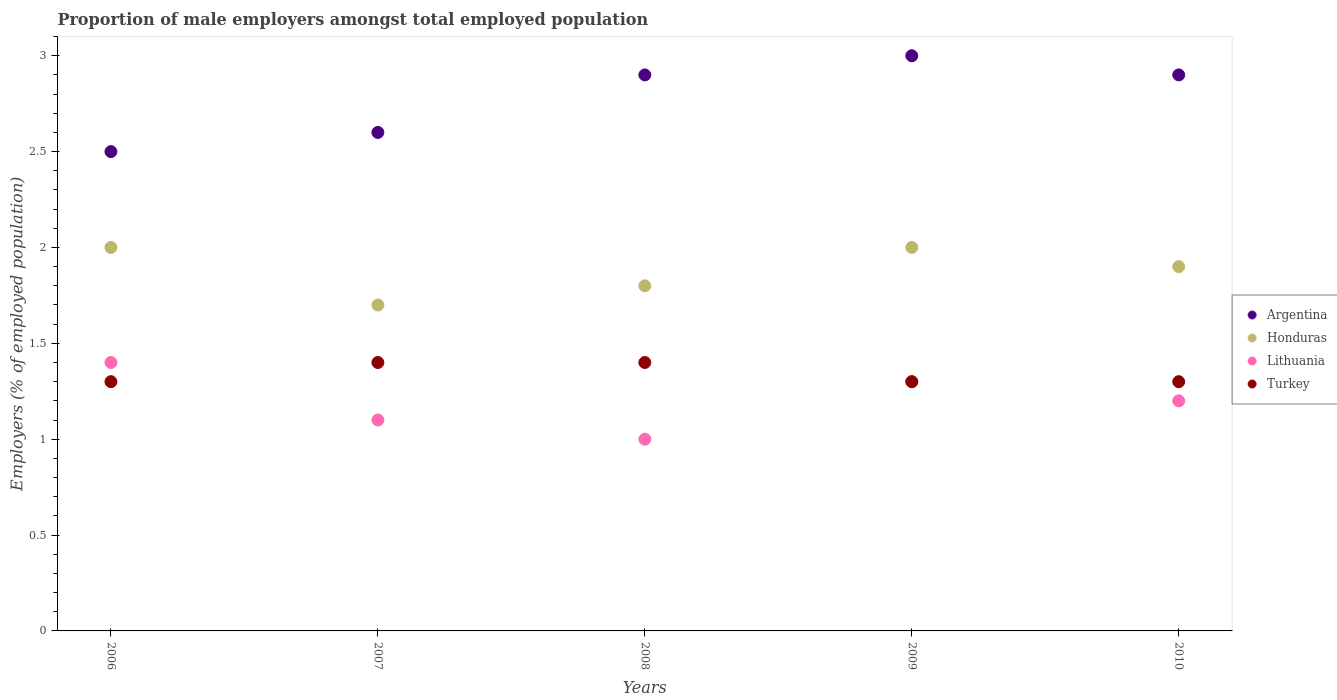Is the number of dotlines equal to the number of legend labels?
Give a very brief answer. Yes. Across all years, what is the maximum proportion of male employers in Turkey?
Your response must be concise. 1.4. Across all years, what is the minimum proportion of male employers in Lithuania?
Offer a terse response. 1. In which year was the proportion of male employers in Turkey minimum?
Your answer should be compact. 2006. What is the total proportion of male employers in Honduras in the graph?
Ensure brevity in your answer.  9.4. What is the difference between the proportion of male employers in Turkey in 2006 and that in 2010?
Keep it short and to the point. 0. What is the difference between the proportion of male employers in Honduras in 2006 and the proportion of male employers in Argentina in 2007?
Offer a very short reply. -0.6. What is the average proportion of male employers in Argentina per year?
Offer a terse response. 2.78. In the year 2010, what is the difference between the proportion of male employers in Lithuania and proportion of male employers in Turkey?
Make the answer very short. -0.1. In how many years, is the proportion of male employers in Lithuania greater than 1.8 %?
Provide a succinct answer. 0. What is the ratio of the proportion of male employers in Lithuania in 2008 to that in 2010?
Ensure brevity in your answer.  0.83. What is the difference between the highest and the second highest proportion of male employers in Honduras?
Your response must be concise. 0. What is the difference between the highest and the lowest proportion of male employers in Lithuania?
Ensure brevity in your answer.  0.4. In how many years, is the proportion of male employers in Honduras greater than the average proportion of male employers in Honduras taken over all years?
Your answer should be compact. 3. Is the sum of the proportion of male employers in Argentina in 2007 and 2010 greater than the maximum proportion of male employers in Honduras across all years?
Your answer should be very brief. Yes. Is the proportion of male employers in Honduras strictly greater than the proportion of male employers in Turkey over the years?
Your response must be concise. Yes. Is the proportion of male employers in Honduras strictly less than the proportion of male employers in Lithuania over the years?
Your response must be concise. No. How many years are there in the graph?
Your answer should be very brief. 5. Are the values on the major ticks of Y-axis written in scientific E-notation?
Your response must be concise. No. Does the graph contain grids?
Make the answer very short. No. How are the legend labels stacked?
Provide a short and direct response. Vertical. What is the title of the graph?
Make the answer very short. Proportion of male employers amongst total employed population. What is the label or title of the X-axis?
Provide a short and direct response. Years. What is the label or title of the Y-axis?
Your answer should be very brief. Employers (% of employed population). What is the Employers (% of employed population) in Argentina in 2006?
Give a very brief answer. 2.5. What is the Employers (% of employed population) in Honduras in 2006?
Your response must be concise. 2. What is the Employers (% of employed population) in Lithuania in 2006?
Make the answer very short. 1.4. What is the Employers (% of employed population) in Turkey in 2006?
Make the answer very short. 1.3. What is the Employers (% of employed population) in Argentina in 2007?
Offer a terse response. 2.6. What is the Employers (% of employed population) of Honduras in 2007?
Give a very brief answer. 1.7. What is the Employers (% of employed population) of Lithuania in 2007?
Your answer should be very brief. 1.1. What is the Employers (% of employed population) in Turkey in 2007?
Your answer should be very brief. 1.4. What is the Employers (% of employed population) of Argentina in 2008?
Offer a terse response. 2.9. What is the Employers (% of employed population) in Honduras in 2008?
Offer a very short reply. 1.8. What is the Employers (% of employed population) in Turkey in 2008?
Your answer should be very brief. 1.4. What is the Employers (% of employed population) in Argentina in 2009?
Make the answer very short. 3. What is the Employers (% of employed population) of Honduras in 2009?
Provide a succinct answer. 2. What is the Employers (% of employed population) of Lithuania in 2009?
Provide a succinct answer. 1.3. What is the Employers (% of employed population) of Turkey in 2009?
Your answer should be very brief. 1.3. What is the Employers (% of employed population) of Argentina in 2010?
Your answer should be compact. 2.9. What is the Employers (% of employed population) of Honduras in 2010?
Make the answer very short. 1.9. What is the Employers (% of employed population) of Lithuania in 2010?
Offer a very short reply. 1.2. What is the Employers (% of employed population) in Turkey in 2010?
Offer a terse response. 1.3. Across all years, what is the maximum Employers (% of employed population) of Honduras?
Make the answer very short. 2. Across all years, what is the maximum Employers (% of employed population) in Lithuania?
Your response must be concise. 1.4. Across all years, what is the maximum Employers (% of employed population) in Turkey?
Give a very brief answer. 1.4. Across all years, what is the minimum Employers (% of employed population) of Argentina?
Give a very brief answer. 2.5. Across all years, what is the minimum Employers (% of employed population) of Honduras?
Your answer should be compact. 1.7. Across all years, what is the minimum Employers (% of employed population) of Lithuania?
Keep it short and to the point. 1. Across all years, what is the minimum Employers (% of employed population) in Turkey?
Your response must be concise. 1.3. What is the total Employers (% of employed population) of Argentina in the graph?
Your response must be concise. 13.9. What is the total Employers (% of employed population) of Honduras in the graph?
Your answer should be very brief. 9.4. What is the total Employers (% of employed population) of Lithuania in the graph?
Make the answer very short. 6. What is the difference between the Employers (% of employed population) in Lithuania in 2006 and that in 2007?
Your answer should be compact. 0.3. What is the difference between the Employers (% of employed population) in Turkey in 2006 and that in 2007?
Your response must be concise. -0.1. What is the difference between the Employers (% of employed population) of Honduras in 2006 and that in 2008?
Keep it short and to the point. 0.2. What is the difference between the Employers (% of employed population) in Turkey in 2006 and that in 2008?
Your answer should be compact. -0.1. What is the difference between the Employers (% of employed population) of Argentina in 2006 and that in 2009?
Provide a short and direct response. -0.5. What is the difference between the Employers (% of employed population) of Honduras in 2006 and that in 2009?
Make the answer very short. 0. What is the difference between the Employers (% of employed population) in Honduras in 2006 and that in 2010?
Offer a terse response. 0.1. What is the difference between the Employers (% of employed population) of Honduras in 2007 and that in 2008?
Your response must be concise. -0.1. What is the difference between the Employers (% of employed population) in Argentina in 2007 and that in 2009?
Offer a terse response. -0.4. What is the difference between the Employers (% of employed population) in Honduras in 2007 and that in 2009?
Your answer should be very brief. -0.3. What is the difference between the Employers (% of employed population) of Turkey in 2007 and that in 2009?
Provide a succinct answer. 0.1. What is the difference between the Employers (% of employed population) in Lithuania in 2007 and that in 2010?
Your answer should be compact. -0.1. What is the difference between the Employers (% of employed population) in Argentina in 2008 and that in 2009?
Give a very brief answer. -0.1. What is the difference between the Employers (% of employed population) of Honduras in 2008 and that in 2010?
Offer a very short reply. -0.1. What is the difference between the Employers (% of employed population) of Honduras in 2009 and that in 2010?
Ensure brevity in your answer.  0.1. What is the difference between the Employers (% of employed population) in Lithuania in 2009 and that in 2010?
Provide a short and direct response. 0.1. What is the difference between the Employers (% of employed population) of Turkey in 2009 and that in 2010?
Make the answer very short. 0. What is the difference between the Employers (% of employed population) in Honduras in 2006 and the Employers (% of employed population) in Turkey in 2008?
Ensure brevity in your answer.  0.6. What is the difference between the Employers (% of employed population) of Lithuania in 2006 and the Employers (% of employed population) of Turkey in 2008?
Provide a short and direct response. 0. What is the difference between the Employers (% of employed population) in Argentina in 2006 and the Employers (% of employed population) in Honduras in 2009?
Make the answer very short. 0.5. What is the difference between the Employers (% of employed population) in Honduras in 2006 and the Employers (% of employed population) in Turkey in 2009?
Give a very brief answer. 0.7. What is the difference between the Employers (% of employed population) of Argentina in 2006 and the Employers (% of employed population) of Honduras in 2010?
Make the answer very short. 0.6. What is the difference between the Employers (% of employed population) of Argentina in 2006 and the Employers (% of employed population) of Turkey in 2010?
Your answer should be very brief. 1.2. What is the difference between the Employers (% of employed population) in Lithuania in 2006 and the Employers (% of employed population) in Turkey in 2010?
Make the answer very short. 0.1. What is the difference between the Employers (% of employed population) of Argentina in 2007 and the Employers (% of employed population) of Lithuania in 2008?
Your response must be concise. 1.6. What is the difference between the Employers (% of employed population) in Lithuania in 2007 and the Employers (% of employed population) in Turkey in 2008?
Offer a very short reply. -0.3. What is the difference between the Employers (% of employed population) in Argentina in 2007 and the Employers (% of employed population) in Honduras in 2009?
Offer a very short reply. 0.6. What is the difference between the Employers (% of employed population) of Argentina in 2007 and the Employers (% of employed population) of Turkey in 2009?
Your answer should be compact. 1.3. What is the difference between the Employers (% of employed population) in Honduras in 2007 and the Employers (% of employed population) in Lithuania in 2009?
Keep it short and to the point. 0.4. What is the difference between the Employers (% of employed population) of Lithuania in 2007 and the Employers (% of employed population) of Turkey in 2009?
Make the answer very short. -0.2. What is the difference between the Employers (% of employed population) of Argentina in 2007 and the Employers (% of employed population) of Honduras in 2010?
Offer a very short reply. 0.7. What is the difference between the Employers (% of employed population) in Argentina in 2007 and the Employers (% of employed population) in Lithuania in 2010?
Make the answer very short. 1.4. What is the difference between the Employers (% of employed population) in Argentina in 2007 and the Employers (% of employed population) in Turkey in 2010?
Ensure brevity in your answer.  1.3. What is the difference between the Employers (% of employed population) of Honduras in 2007 and the Employers (% of employed population) of Lithuania in 2010?
Your answer should be compact. 0.5. What is the difference between the Employers (% of employed population) in Honduras in 2007 and the Employers (% of employed population) in Turkey in 2010?
Make the answer very short. 0.4. What is the difference between the Employers (% of employed population) in Lithuania in 2007 and the Employers (% of employed population) in Turkey in 2010?
Offer a very short reply. -0.2. What is the difference between the Employers (% of employed population) of Honduras in 2008 and the Employers (% of employed population) of Turkey in 2009?
Your answer should be compact. 0.5. What is the difference between the Employers (% of employed population) of Lithuania in 2008 and the Employers (% of employed population) of Turkey in 2009?
Provide a succinct answer. -0.3. What is the difference between the Employers (% of employed population) of Argentina in 2008 and the Employers (% of employed population) of Honduras in 2010?
Offer a very short reply. 1. What is the difference between the Employers (% of employed population) of Argentina in 2008 and the Employers (% of employed population) of Turkey in 2010?
Your response must be concise. 1.6. What is the difference between the Employers (% of employed population) in Honduras in 2008 and the Employers (% of employed population) in Turkey in 2010?
Keep it short and to the point. 0.5. What is the difference between the Employers (% of employed population) of Lithuania in 2008 and the Employers (% of employed population) of Turkey in 2010?
Your answer should be compact. -0.3. What is the difference between the Employers (% of employed population) of Argentina in 2009 and the Employers (% of employed population) of Honduras in 2010?
Give a very brief answer. 1.1. What is the difference between the Employers (% of employed population) of Honduras in 2009 and the Employers (% of employed population) of Lithuania in 2010?
Provide a short and direct response. 0.8. What is the difference between the Employers (% of employed population) of Lithuania in 2009 and the Employers (% of employed population) of Turkey in 2010?
Your answer should be very brief. 0. What is the average Employers (% of employed population) of Argentina per year?
Your response must be concise. 2.78. What is the average Employers (% of employed population) of Honduras per year?
Offer a terse response. 1.88. What is the average Employers (% of employed population) of Turkey per year?
Offer a very short reply. 1.34. In the year 2006, what is the difference between the Employers (% of employed population) of Argentina and Employers (% of employed population) of Honduras?
Provide a succinct answer. 0.5. In the year 2006, what is the difference between the Employers (% of employed population) in Argentina and Employers (% of employed population) in Lithuania?
Ensure brevity in your answer.  1.1. In the year 2006, what is the difference between the Employers (% of employed population) of Lithuania and Employers (% of employed population) of Turkey?
Your answer should be very brief. 0.1. In the year 2007, what is the difference between the Employers (% of employed population) of Argentina and Employers (% of employed population) of Lithuania?
Offer a very short reply. 1.5. In the year 2007, what is the difference between the Employers (% of employed population) in Honduras and Employers (% of employed population) in Lithuania?
Make the answer very short. 0.6. In the year 2007, what is the difference between the Employers (% of employed population) in Lithuania and Employers (% of employed population) in Turkey?
Offer a terse response. -0.3. In the year 2008, what is the difference between the Employers (% of employed population) of Argentina and Employers (% of employed population) of Lithuania?
Offer a very short reply. 1.9. In the year 2008, what is the difference between the Employers (% of employed population) in Honduras and Employers (% of employed population) in Turkey?
Your answer should be compact. 0.4. In the year 2009, what is the difference between the Employers (% of employed population) in Argentina and Employers (% of employed population) in Honduras?
Give a very brief answer. 1. In the year 2009, what is the difference between the Employers (% of employed population) in Honduras and Employers (% of employed population) in Lithuania?
Provide a short and direct response. 0.7. In the year 2010, what is the difference between the Employers (% of employed population) of Honduras and Employers (% of employed population) of Lithuania?
Offer a very short reply. 0.7. What is the ratio of the Employers (% of employed population) in Argentina in 2006 to that in 2007?
Your response must be concise. 0.96. What is the ratio of the Employers (% of employed population) of Honduras in 2006 to that in 2007?
Your response must be concise. 1.18. What is the ratio of the Employers (% of employed population) of Lithuania in 2006 to that in 2007?
Give a very brief answer. 1.27. What is the ratio of the Employers (% of employed population) of Argentina in 2006 to that in 2008?
Provide a succinct answer. 0.86. What is the ratio of the Employers (% of employed population) of Honduras in 2006 to that in 2009?
Your response must be concise. 1. What is the ratio of the Employers (% of employed population) in Turkey in 2006 to that in 2009?
Your answer should be compact. 1. What is the ratio of the Employers (% of employed population) of Argentina in 2006 to that in 2010?
Offer a very short reply. 0.86. What is the ratio of the Employers (% of employed population) of Honduras in 2006 to that in 2010?
Your answer should be very brief. 1.05. What is the ratio of the Employers (% of employed population) of Lithuania in 2006 to that in 2010?
Offer a terse response. 1.17. What is the ratio of the Employers (% of employed population) in Turkey in 2006 to that in 2010?
Ensure brevity in your answer.  1. What is the ratio of the Employers (% of employed population) of Argentina in 2007 to that in 2008?
Offer a very short reply. 0.9. What is the ratio of the Employers (% of employed population) of Honduras in 2007 to that in 2008?
Offer a very short reply. 0.94. What is the ratio of the Employers (% of employed population) in Turkey in 2007 to that in 2008?
Provide a succinct answer. 1. What is the ratio of the Employers (% of employed population) of Argentina in 2007 to that in 2009?
Keep it short and to the point. 0.87. What is the ratio of the Employers (% of employed population) in Lithuania in 2007 to that in 2009?
Keep it short and to the point. 0.85. What is the ratio of the Employers (% of employed population) in Argentina in 2007 to that in 2010?
Ensure brevity in your answer.  0.9. What is the ratio of the Employers (% of employed population) of Honduras in 2007 to that in 2010?
Your answer should be very brief. 0.89. What is the ratio of the Employers (% of employed population) in Turkey in 2007 to that in 2010?
Your response must be concise. 1.08. What is the ratio of the Employers (% of employed population) in Argentina in 2008 to that in 2009?
Keep it short and to the point. 0.97. What is the ratio of the Employers (% of employed population) in Lithuania in 2008 to that in 2009?
Give a very brief answer. 0.77. What is the ratio of the Employers (% of employed population) of Turkey in 2008 to that in 2009?
Your response must be concise. 1.08. What is the ratio of the Employers (% of employed population) in Argentina in 2008 to that in 2010?
Your answer should be compact. 1. What is the ratio of the Employers (% of employed population) in Honduras in 2008 to that in 2010?
Your answer should be very brief. 0.95. What is the ratio of the Employers (% of employed population) of Lithuania in 2008 to that in 2010?
Offer a terse response. 0.83. What is the ratio of the Employers (% of employed population) in Argentina in 2009 to that in 2010?
Offer a terse response. 1.03. What is the ratio of the Employers (% of employed population) in Honduras in 2009 to that in 2010?
Provide a succinct answer. 1.05. What is the difference between the highest and the second highest Employers (% of employed population) in Argentina?
Keep it short and to the point. 0.1. What is the difference between the highest and the second highest Employers (% of employed population) of Honduras?
Ensure brevity in your answer.  0. What is the difference between the highest and the second highest Employers (% of employed population) of Turkey?
Your answer should be very brief. 0. What is the difference between the highest and the lowest Employers (% of employed population) in Turkey?
Make the answer very short. 0.1. 